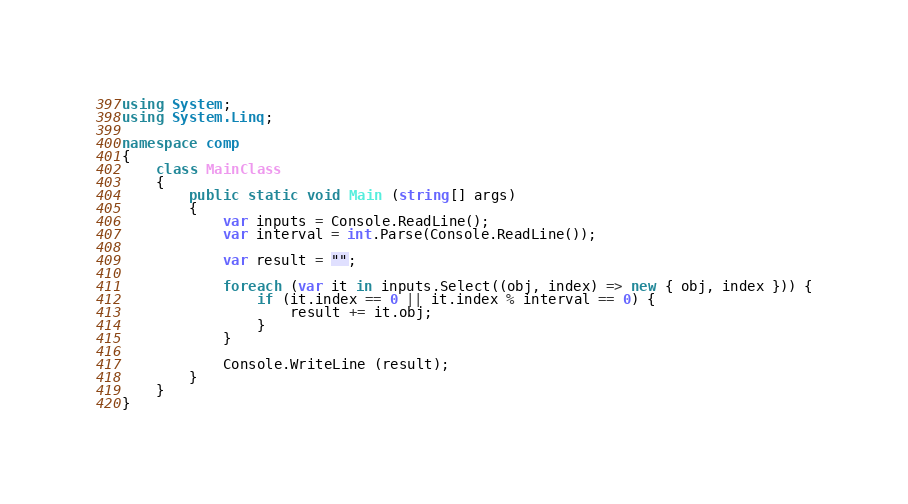<code> <loc_0><loc_0><loc_500><loc_500><_C#_>using System;
using System.Linq;

namespace comp
{
	class MainClass
	{
		public static void Main (string[] args)
		{
			var inputs = Console.ReadLine();
			var interval = int.Parse(Console.ReadLine());

			var result = "";

			foreach (var it in inputs.Select((obj, index) => new { obj, index })) {
				if (it.index == 0 || it.index % interval == 0) {
					result += it.obj;
				}
			}

			Console.WriteLine (result);
		}
	}
}
</code> 